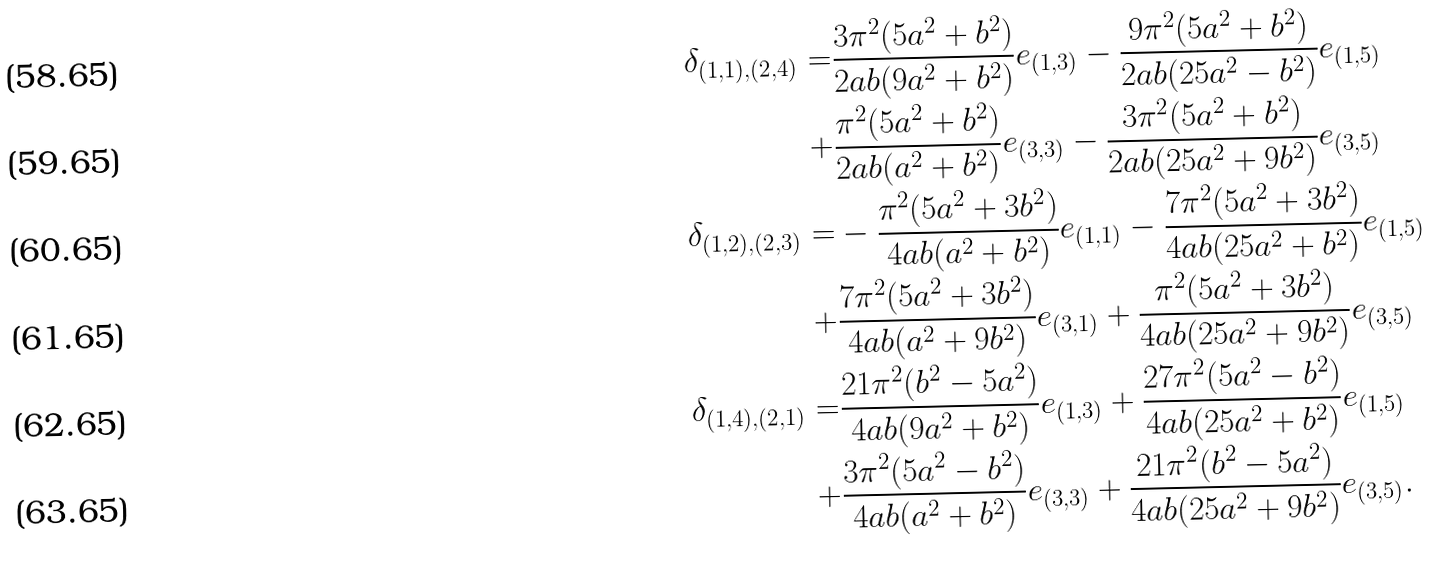Convert formula to latex. <formula><loc_0><loc_0><loc_500><loc_500>\delta _ { ( 1 , 1 ) , ( 2 , 4 ) } = & \frac { 3 \pi ^ { 2 } ( 5 a ^ { 2 } + b ^ { 2 } ) } { 2 a b ( 9 a ^ { 2 } + b ^ { 2 } ) } e _ { ( 1 , 3 ) } - \frac { 9 \pi ^ { 2 } ( 5 a ^ { 2 } + b ^ { 2 } ) } { 2 a b ( 2 5 a ^ { 2 } - b ^ { 2 } ) } e _ { ( 1 , 5 ) } \\ + & \frac { \pi ^ { 2 } ( 5 a ^ { 2 } + b ^ { 2 } ) } { 2 a b ( a ^ { 2 } + b ^ { 2 } ) } e _ { ( 3 , 3 ) } - \frac { 3 \pi ^ { 2 } ( 5 a ^ { 2 } + b ^ { 2 } ) } { 2 a b ( 2 5 a ^ { 2 } + 9 b ^ { 2 } ) } e _ { ( 3 , 5 ) } \\ \delta _ { ( 1 , 2 ) , ( 2 , 3 ) } = & - \frac { \pi ^ { 2 } ( 5 a ^ { 2 } + 3 b ^ { 2 } ) } { 4 a b ( a ^ { 2 } + b ^ { 2 } ) } e _ { ( 1 , 1 ) } - \frac { 7 \pi ^ { 2 } ( 5 a ^ { 2 } + 3 b ^ { 2 } ) } { 4 a b ( 2 5 a ^ { 2 } + b ^ { 2 } ) } e _ { ( 1 , 5 ) } \\ + & \frac { 7 \pi ^ { 2 } ( 5 a ^ { 2 } + 3 b ^ { 2 } ) } { 4 a b ( a ^ { 2 } + 9 b ^ { 2 } ) } e _ { ( 3 , 1 ) } + \frac { \pi ^ { 2 } ( 5 a ^ { 2 } + 3 b ^ { 2 } ) } { 4 a b ( 2 5 a ^ { 2 } + 9 b ^ { 2 } ) } e _ { ( 3 , 5 ) } \\ \delta _ { ( 1 , 4 ) , ( 2 , 1 ) } = & \frac { 2 1 \pi ^ { 2 } ( b ^ { 2 } - 5 a ^ { 2 } ) } { 4 a b ( 9 a ^ { 2 } + b ^ { 2 } ) } e _ { ( 1 , 3 ) } + \frac { 2 7 \pi ^ { 2 } ( 5 a ^ { 2 } - b ^ { 2 } ) } { 4 a b ( 2 5 a ^ { 2 } + b ^ { 2 } ) } e _ { ( 1 , 5 ) } \\ + & \frac { 3 \pi ^ { 2 } ( 5 a ^ { 2 } - b ^ { 2 } ) } { 4 a b ( a ^ { 2 } + b ^ { 2 } ) } e _ { ( 3 , 3 ) } + \frac { 2 1 \pi ^ { 2 } ( b ^ { 2 } - 5 a ^ { 2 } ) } { 4 a b ( 2 5 a ^ { 2 } + 9 b ^ { 2 } ) } e _ { ( 3 , 5 ) } .</formula> 